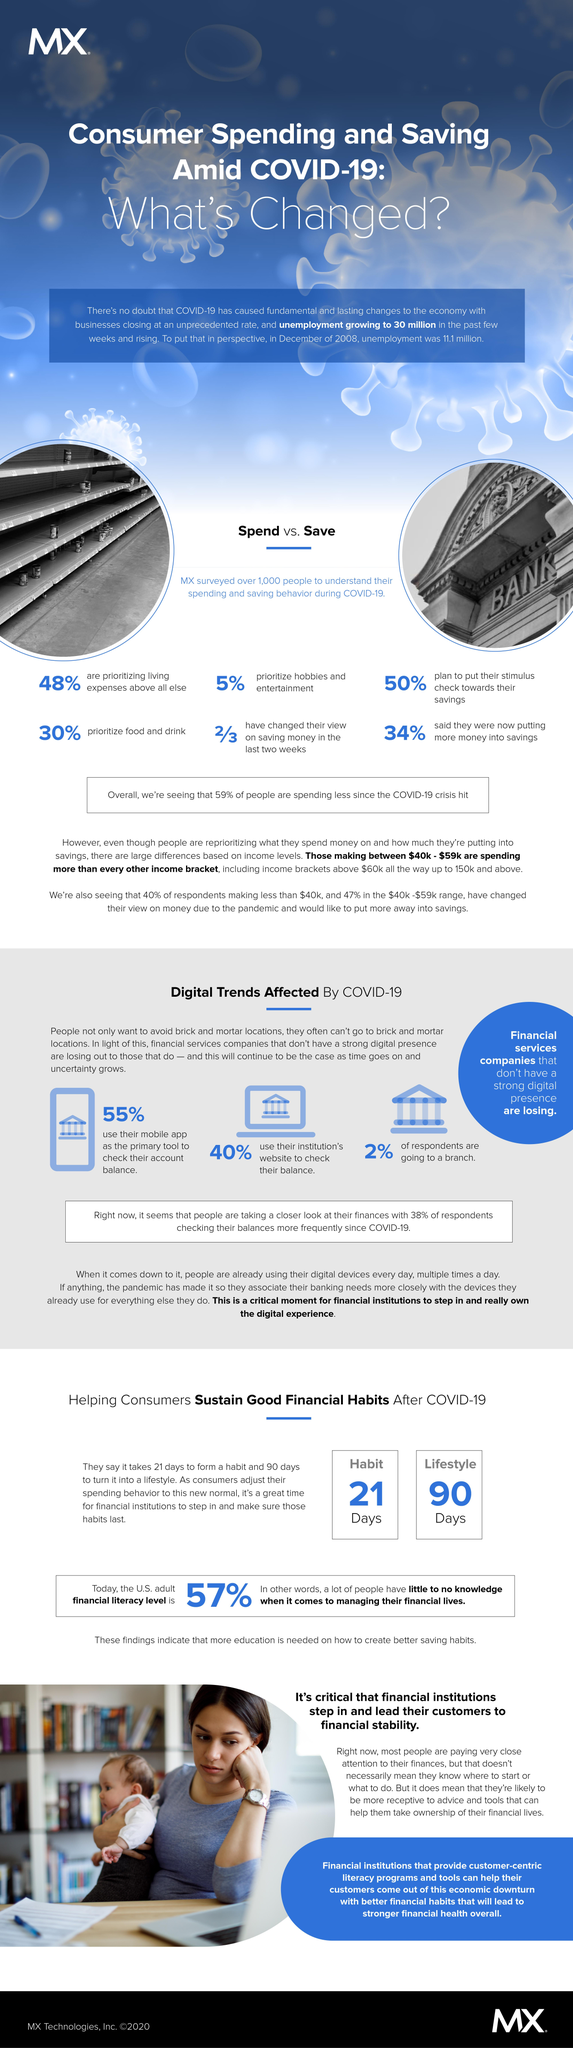Specify some key components in this picture. According to a recent survey, 40% of people use their institution's website to check their balance due to the pandemic. According to a recent survey, a significant number of people, approximately 70%, do not prioritize food and drink amid the COVID-19 pandemic. According to a recent survey, a significant 34% of people are putting more money into savings due to the Covid-19 pandemic. During the COVID-19 pandemic, it appears that a significant percentage of people do not prioritize hobbies and entertainment. According to a recent survey, 95% of respondents reported that they did not place a high priority on these activities during the pandemic. During the COVID-19 pandemic, 45% of individuals do not rely on their mobile app as their primary means of checking their account balance. 